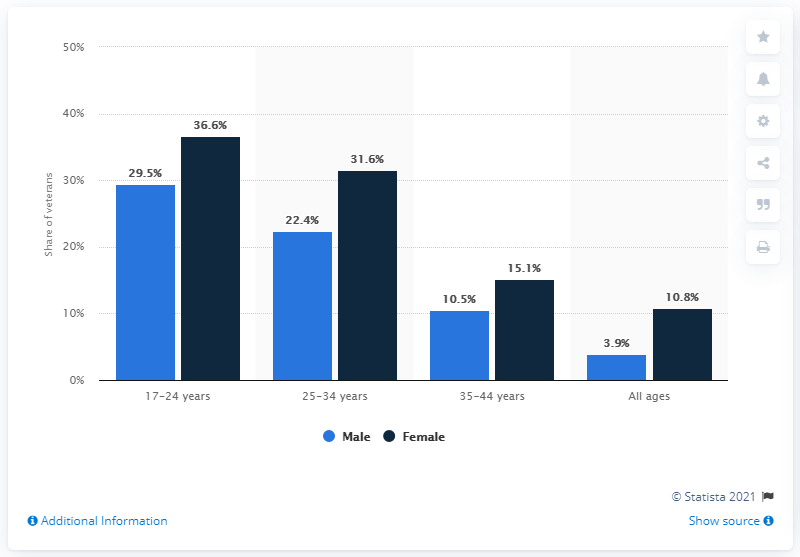Highlight a few significant elements in this photo. In 2017, approximately 10.5% of U.S. male veterans were enrolled in college. 